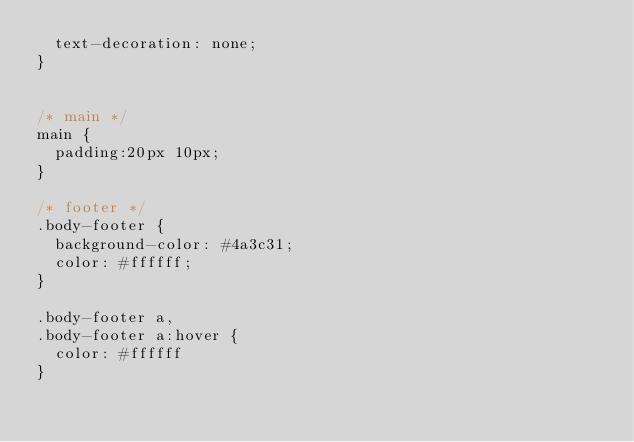<code> <loc_0><loc_0><loc_500><loc_500><_CSS_>  text-decoration: none;
}


/* main */
main {
  padding:20px 10px;
}

/* footer */
.body-footer {
  background-color: #4a3c31;
  color: #ffffff;
}

.body-footer a,
.body-footer a:hover {
  color: #ffffff
}
</code> 